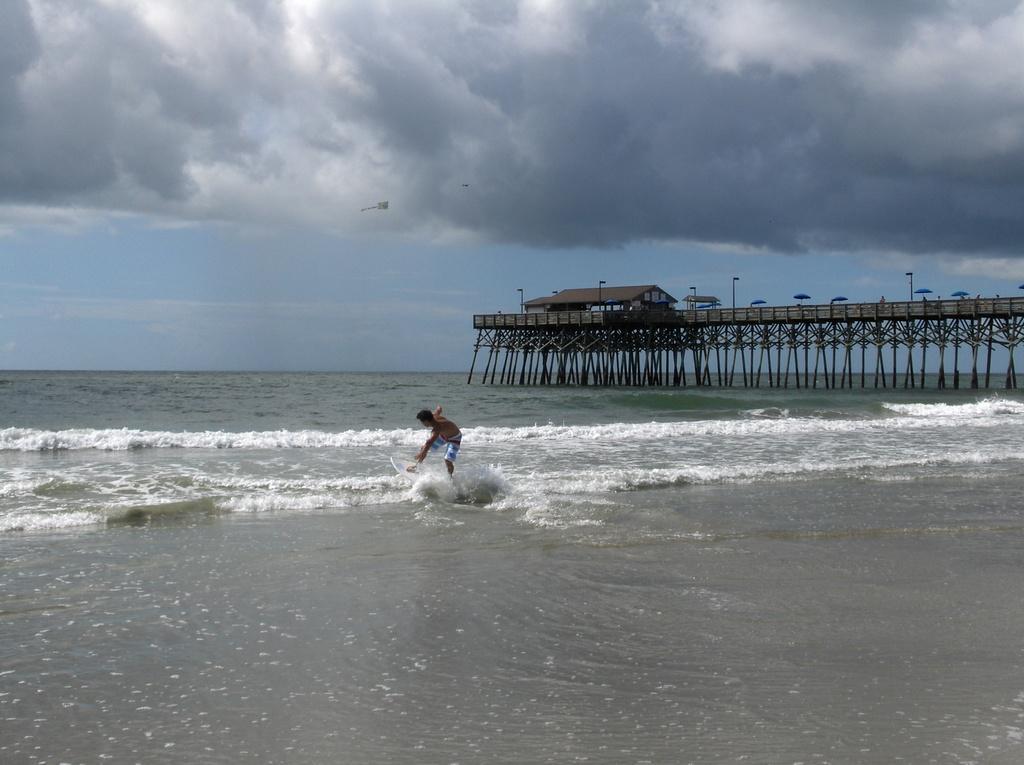In one or two sentences, can you explain what this image depicts? In this picture there is a man and we can see water, bridge, umbrellas, house and light poles. In the background of the image we can see the sky with clouds. 